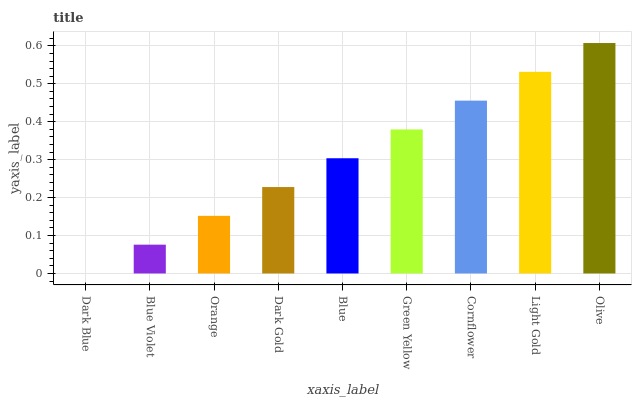Is Dark Blue the minimum?
Answer yes or no. Yes. Is Olive the maximum?
Answer yes or no. Yes. Is Blue Violet the minimum?
Answer yes or no. No. Is Blue Violet the maximum?
Answer yes or no. No. Is Blue Violet greater than Dark Blue?
Answer yes or no. Yes. Is Dark Blue less than Blue Violet?
Answer yes or no. Yes. Is Dark Blue greater than Blue Violet?
Answer yes or no. No. Is Blue Violet less than Dark Blue?
Answer yes or no. No. Is Blue the high median?
Answer yes or no. Yes. Is Blue the low median?
Answer yes or no. Yes. Is Orange the high median?
Answer yes or no. No. Is Olive the low median?
Answer yes or no. No. 